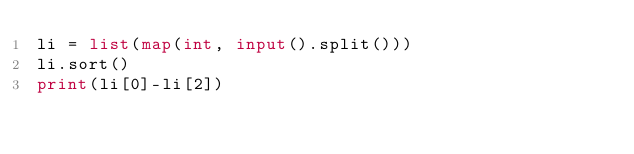Convert code to text. <code><loc_0><loc_0><loc_500><loc_500><_Python_>li = list(map(int, input().split()))
li.sort()
print(li[0]-li[2])</code> 